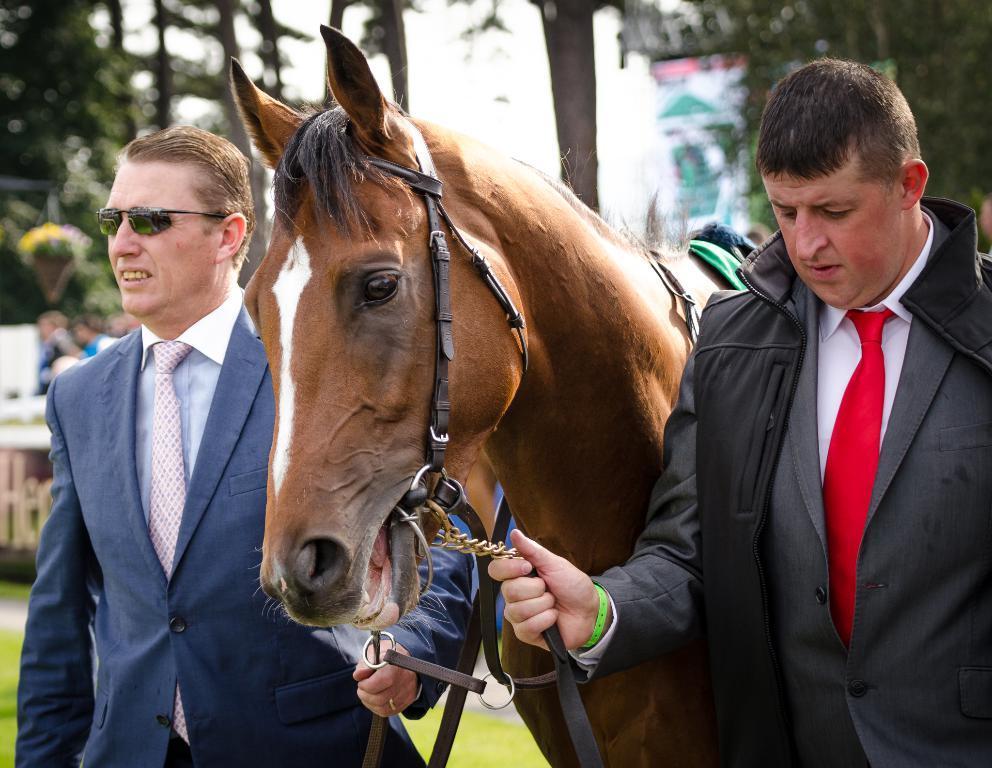Describe this image in one or two sentences. As we can see in the image there is a tree, two people standing over here and there is a horse. 